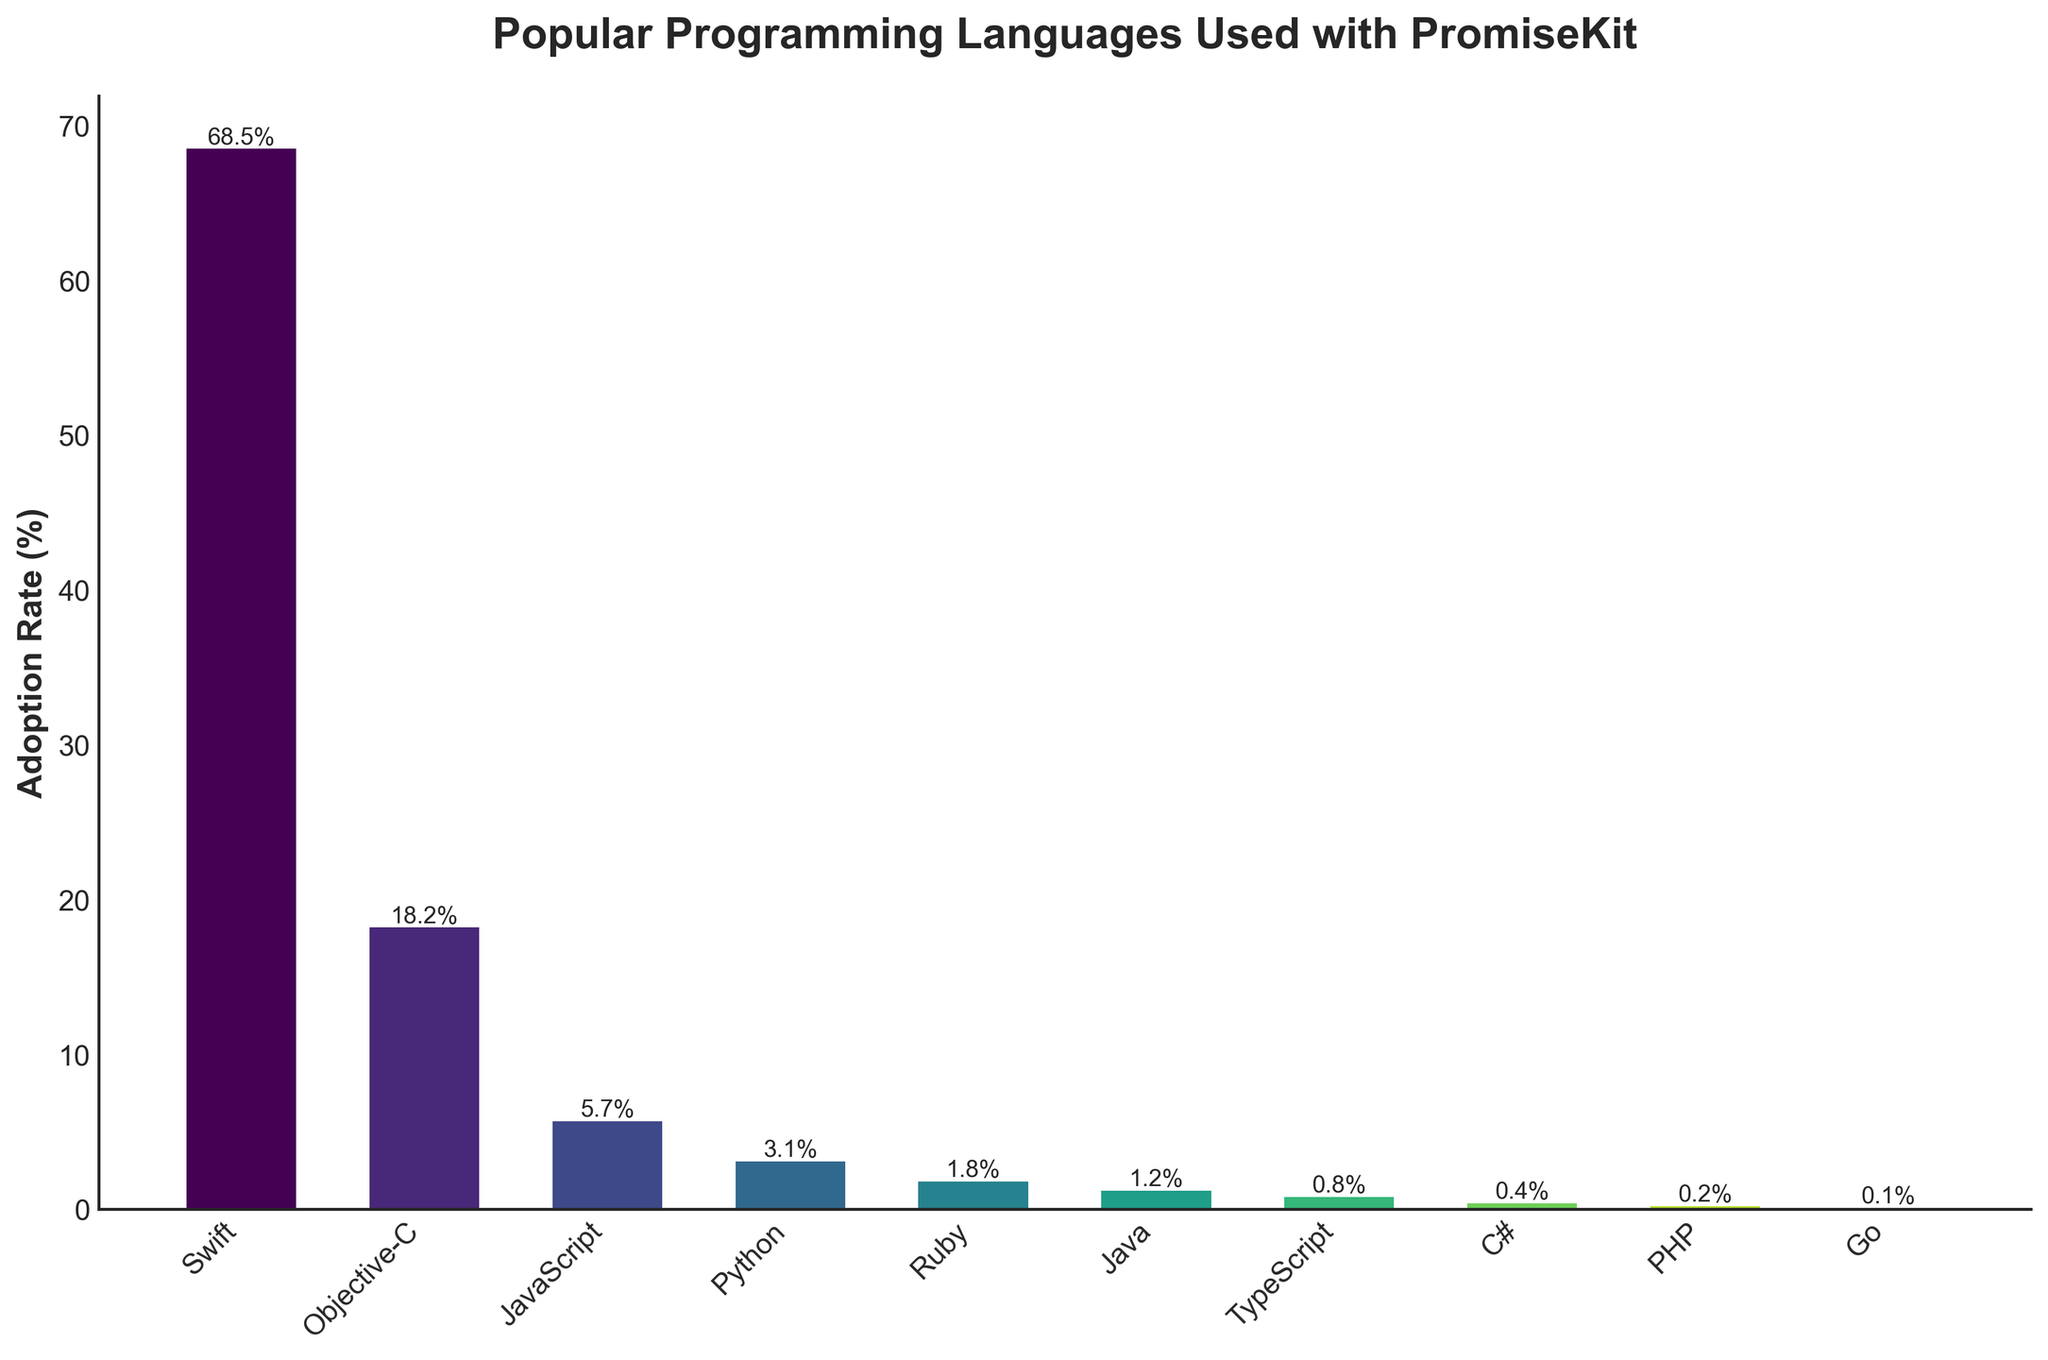Which language has the highest adoption rate? By looking at the heights of the bars, we see that Swift is the tallest, indicating it has the highest adoption rate
Answer: Swift Which language has the lowest adoption rate? By observing the shortest bar, we see that Go has the lowest adoption rate
Answer: Go What is the total adoption rate of JavaScript, Python, and Ruby combined? Add the adoption rates of JavaScript (5.7), Python (3.1), and Ruby (1.8): 5.7 + 3.1 + 1.8 = 10.6
Answer: 10.6 How much higher is the adoption rate of Swift compared to Objective-C? Subtract Objective-C's adoption rate (18.2) from Swift's (68.5): 68.5 - 18.2 = 50.3
Answer: 50.3 Which language has a higher adoption rate: Java or TypeScript? Compare the heights of the bars for Java (1.2) and TypeScript (0.8); Java's bar is taller
Answer: Java What is the average adoption rate of languages other than Swift and Objective-C? Sum the adoption rates of JavaScript (5.7), Python (3.1), Ruby (1.8), Java (1.2), TypeScript (0.8), C# (0.4), PHP (0.2), and Go (0.1): 13.3. Divide by the number of languages (8): 13.3 / 8 = 1.6625
Answer: 1.6625 Which language ranks third in adoption rate? By examining the bar heights in descending order, JavaScript is the third tallest bar (5.7)
Answer: JavaScript How many languages have an adoption rate above 1%? Count the bars that are taller than 1%: Swift, Objective-C, JavaScript, Python, and Ruby. Total = 5
Answer: 5 What is the difference in adoption rate between the language with the highest and lowest adoption rates? Subtract Go's adoption rate (0.1) from Swift's (68.5): 68.5 - 0.1 = 68.4
Answer: 68.4 What is the combined adoption rate of all languages shown in the chart? Sum all the adoption rates: 68.5 + 18.2 + 5.7 + 3.1 + 1.8 + 1.2 + 0.8 + 0.4 + 0.2 + 0.1 = 100
Answer: 100 